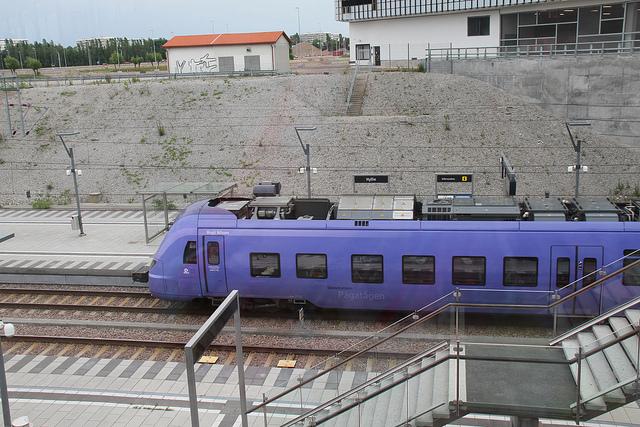Is the train tracks above sea level?
Write a very short answer. No. Where do the pictured stairs probably lead to?
Short answer required. Train platform. What color is the train?
Give a very brief answer. Purple. 